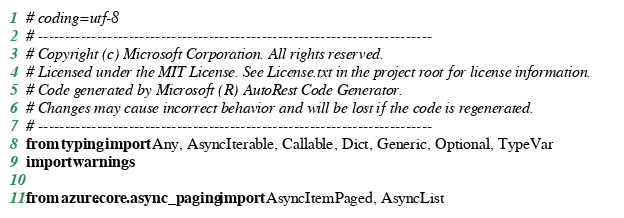Convert code to text. <code><loc_0><loc_0><loc_500><loc_500><_Python_># coding=utf-8
# --------------------------------------------------------------------------
# Copyright (c) Microsoft Corporation. All rights reserved.
# Licensed under the MIT License. See License.txt in the project root for license information.
# Code generated by Microsoft (R) AutoRest Code Generator.
# Changes may cause incorrect behavior and will be lost if the code is regenerated.
# --------------------------------------------------------------------------
from typing import Any, AsyncIterable, Callable, Dict, Generic, Optional, TypeVar
import warnings

from azure.core.async_paging import AsyncItemPaged, AsyncList</code> 